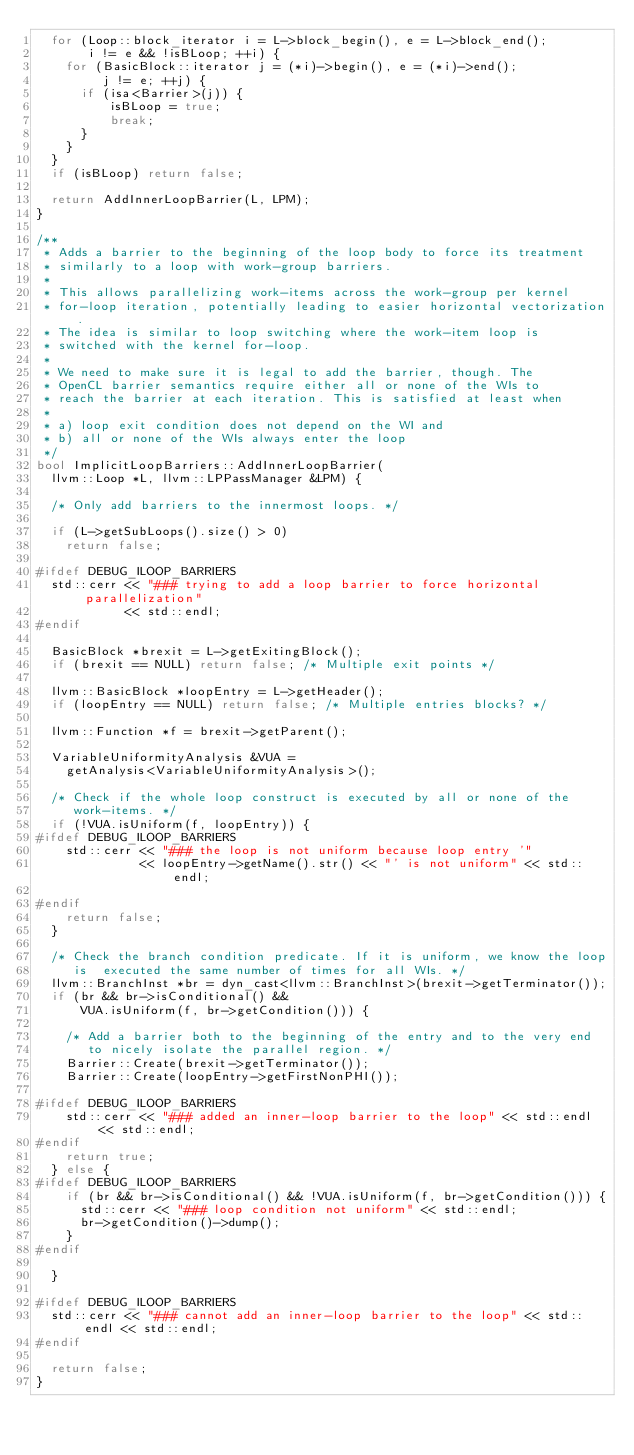Convert code to text. <code><loc_0><loc_0><loc_500><loc_500><_C++_>  for (Loop::block_iterator i = L->block_begin(), e = L->block_end();
       i != e && !isBLoop; ++i) {
    for (BasicBlock::iterator j = (*i)->begin(), e = (*i)->end();
         j != e; ++j) {
      if (isa<Barrier>(j)) {
          isBLoop = true;
          break;
      }
    }
  }
  if (isBLoop) return false;

  return AddInnerLoopBarrier(L, LPM);
}

/**
 * Adds a barrier to the beginning of the loop body to force its treatment 
 * similarly to a loop with work-group barriers.
 *
 * This allows parallelizing work-items across the work-group per kernel
 * for-loop iteration, potentially leading to easier horizontal vectorization.
 * The idea is similar to loop switching where the work-item loop is 
 * switched with the kernel for-loop.
 *
 * We need to make sure it is legal to add the barrier, though. The
 * OpenCL barrier semantics require either all or none of the WIs to
 * reach the barrier at each iteration. This is satisfied at least when
 *
 * a) loop exit condition does not depend on the WI and 
 * b) all or none of the WIs always enter the loop
 */
bool ImplicitLoopBarriers::AddInnerLoopBarrier(
  llvm::Loop *L, llvm::LPPassManager &LPM) {

  /* Only add barriers to the innermost loops. */

  if (L->getSubLoops().size() > 0)
    return false;

#ifdef DEBUG_ILOOP_BARRIERS
  std::cerr << "### trying to add a loop barrier to force horizontal parallelization" 
            << std::endl;
#endif

  BasicBlock *brexit = L->getExitingBlock();
  if (brexit == NULL) return false; /* Multiple exit points */

  llvm::BasicBlock *loopEntry = L->getHeader();
  if (loopEntry == NULL) return false; /* Multiple entries blocks? */

  llvm::Function *f = brexit->getParent();

  VariableUniformityAnalysis &VUA = 
    getAnalysis<VariableUniformityAnalysis>();

  /* Check if the whole loop construct is executed by all or none of the
     work-items. */
  if (!VUA.isUniform(f, loopEntry)) {
#ifdef DEBUG_ILOOP_BARRIERS
    std::cerr << "### the loop is not uniform because loop entry '"
              << loopEntry->getName().str() << "' is not uniform" << std::endl;
    
#endif
    return false;
  }

  /* Check the branch condition predicate. If it is uniform, we know the loop 
     is  executed the same number of times for all WIs. */
  llvm::BranchInst *br = dyn_cast<llvm::BranchInst>(brexit->getTerminator());  
  if (br && br->isConditional() &&
      VUA.isUniform(f, br->getCondition())) {

    /* Add a barrier both to the beginning of the entry and to the very end
       to nicely isolate the parallel region. */
    Barrier::Create(brexit->getTerminator());   
    Barrier::Create(loopEntry->getFirstNonPHI());

#ifdef DEBUG_ILOOP_BARRIERS
    std::cerr << "### added an inner-loop barrier to the loop" << std::endl << std::endl;
#endif
    return true;
  } else {
#ifdef DEBUG_ILOOP_BARRIERS
    if (br && br->isConditional() && !VUA.isUniform(f, br->getCondition())) {
      std::cerr << "### loop condition not uniform" << std::endl;
      br->getCondition()->dump();
    }
#endif

  }

#ifdef DEBUG_ILOOP_BARRIERS
  std::cerr << "### cannot add an inner-loop barrier to the loop" << std::endl << std::endl;
#endif
  
  return false;
}
</code> 